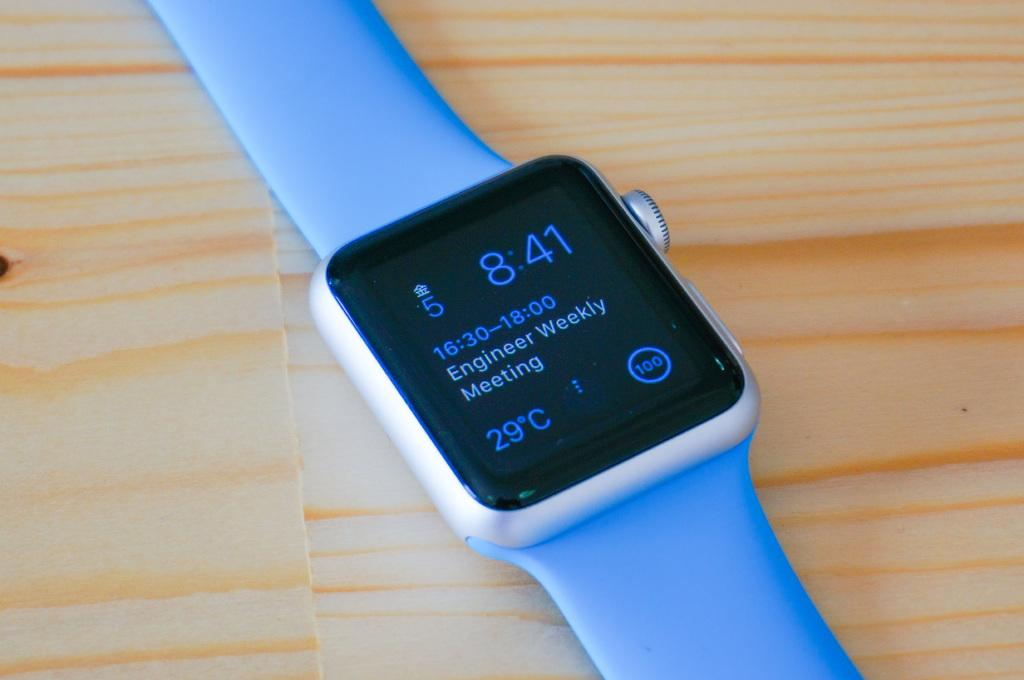<image>
Provide a brief description of the given image. A smart watch shows a meeting notification among other pieces of information. 